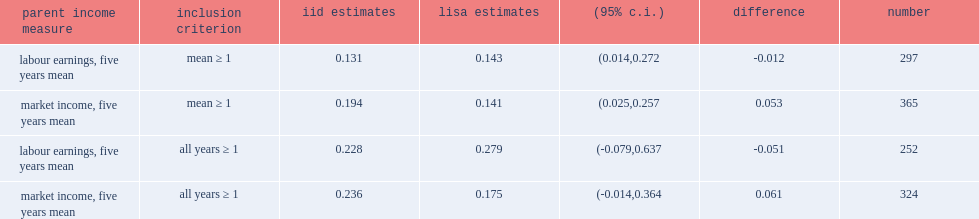What were coefficients for labour earnings with a restriction based on mean parental income? 0.143. What were coefficients for market income with a restriction based on mean parental income? 0.141. What were coefficients for labour earnings when restricting the parents to those with positive income on all years? 0.279. What were coefficients for market income when restricting the parents to those with positive income on all years? 0.175. 